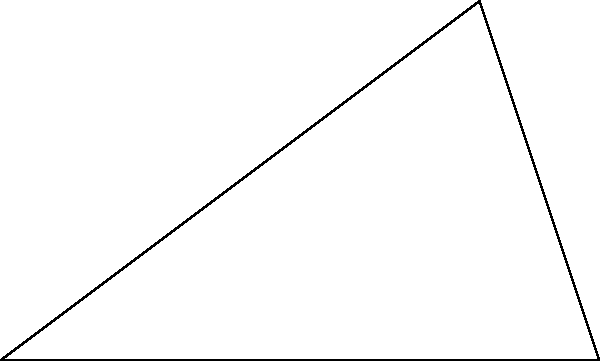You're planning your first family vacation and considering two possible flight routes. On a map, the first route is 3000 km long, and the second is 4000 km. If these routes form a right angle, what is the angle between them when viewed from your departure city? Let's approach this step-by-step:

1) In the diagram, we have a right-angled triangle ABC, where:
   - AB represents the 3000 km route
   - BC represents the 4000 km route
   - Angle ACB is a right angle (90°)

2) We need to find angle BAC. Let's call this angle $\theta$.

3) We can use the trigonometric function tangent (tan) to find this angle:

   $\tan \theta = \frac{\text{opposite}}{\text{adjacent}} = \frac{BC}{AB} = \frac{4000}{3000}$

4) To find $\theta$, we need to use the inverse tangent (arctan or $\tan^{-1}$):

   $\theta = \tan^{-1}(\frac{4000}{3000})$

5) Simplifying the fraction:

   $\theta = \tan^{-1}(\frac{4}{3})$

6) Using a calculator or trigonometric tables:

   $\theta \approx 53.13°$

Therefore, the angle between the two flight routes, when viewed from your departure city, is approximately 53.13°.
Answer: $53.13°$ 